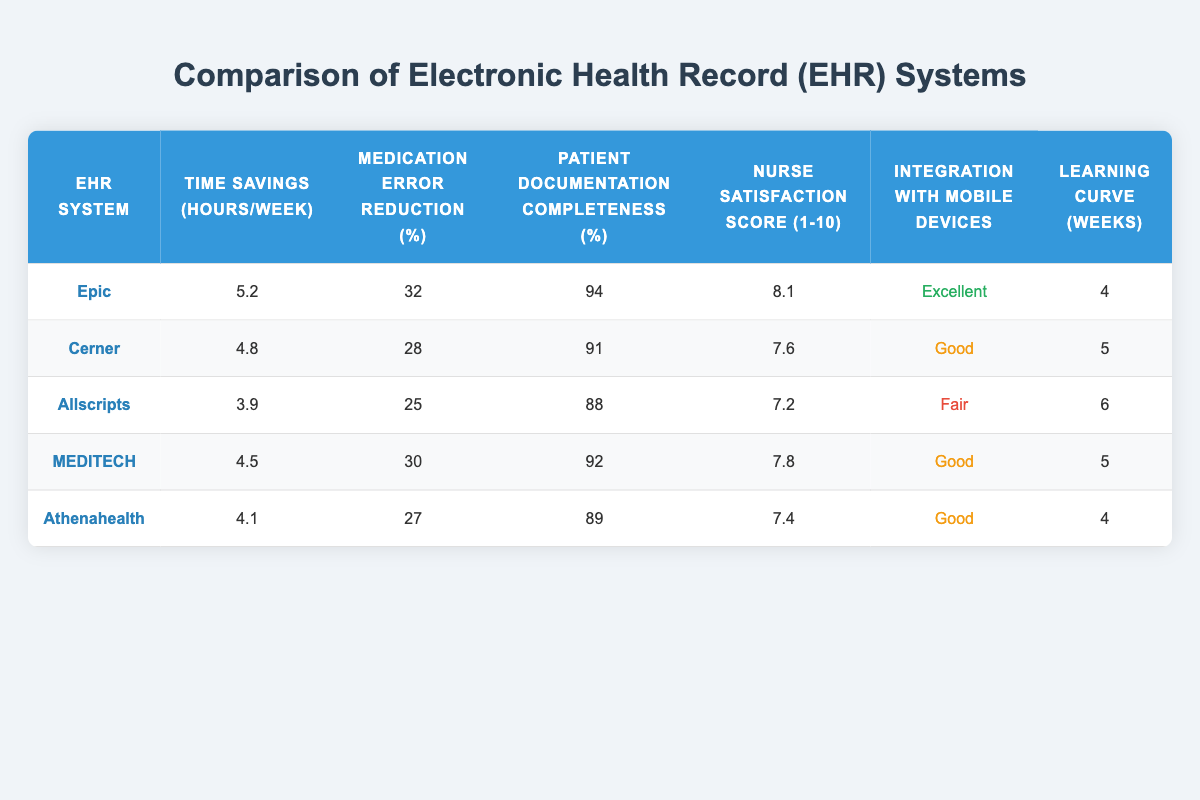What is the nurse satisfaction score for Epic? The nurse satisfaction score for Epic is listed in the table as 8.1.
Answer: 8.1 Which EHR system has the highest time savings per week? The highest time savings per week is 5.2 hours, attributed to the Epic EHR system, which is the highest among the listed systems in the table.
Answer: Epic What is the median medication error reduction percentage among the EHR systems? To find the median, first list the medication error reduction percentages in order: 25, 27, 28, 30, 32. The median is the middle value of this sorted list, which is 28.
Answer: 28 Is it true that Allscripts has the lowest patient documentation completeness? Yes, by checking the patient documentation completeness percentages, Allscripts has a score of 88%, which is lower than all the other EHR systems.
Answer: Yes What is the average learning curve in weeks for the EHR systems? The learning curves are 4, 5, 6, 5, and 4 weeks. Summing these gives 20 weeks, and dividing by the number of systems (5) results in an average learning curve of 4 weeks.
Answer: 4 Which system has a "Fair" integration with mobile devices and what is its nurse satisfaction score? Allscripts has "Fair" integration with mobile devices and has a nurse satisfaction score of 7.2.
Answer: Allscripts, 7.2 How much time savings is there between the EHR systems with the highest and lowest time savings? Epic's time savings is 5.2 hours and Allscripts' time savings is 3.9 hours. The difference between these two values is 5.2 - 3.9 = 1.3 hours.
Answer: 1.3 hours Which EHR system has a longer learning curve than MEDITECH? Allscripts has a learning curve of 6 weeks, which is longer than MEDITECH's learning curve of 5 weeks.
Answer: Allscripts What percentage of medication error reduction does Athenahealth have? Athenahealth has a medication error reduction percentage listed as 27%.
Answer: 27% 